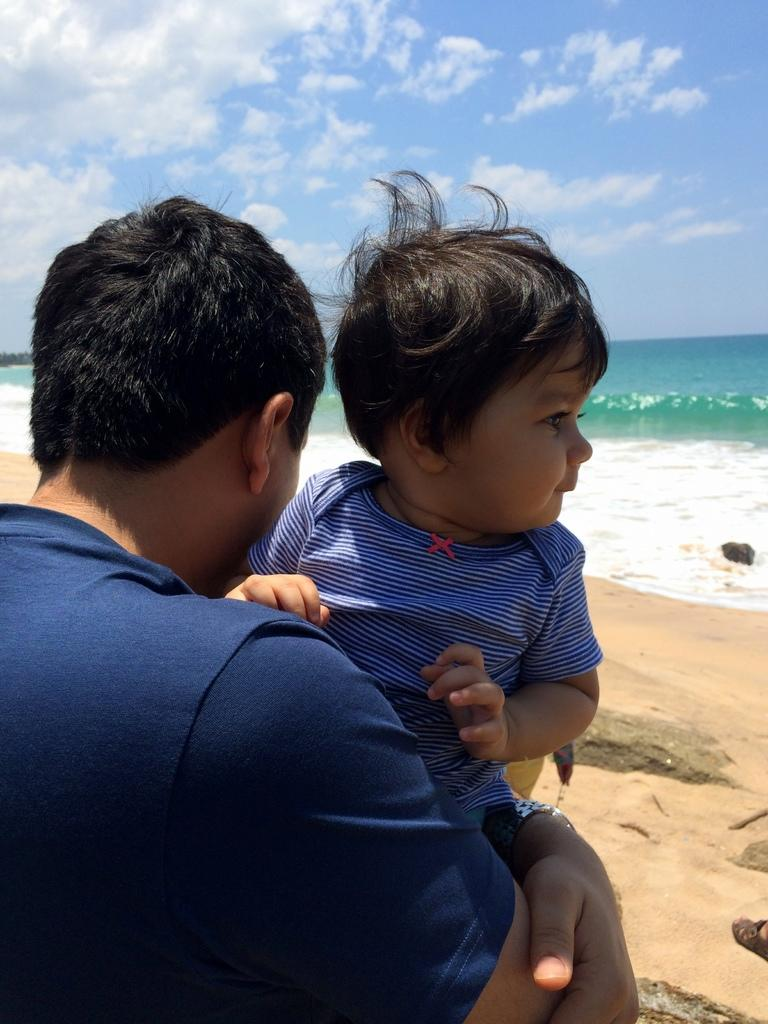What is the main subject of the image? There is a person in the image. What is the person wearing? The person is wearing clothes. What is the person doing with his hands? The person is holding a baby with his hands. What can be seen in the middle of the image? There is a sea in the middle of the image. What is visible at the top of the image? There is a sky at the top of the image. What type of bottle is being used to stir the sea in the image? There is no bottle present in the image, and the sea is not being stirred. 